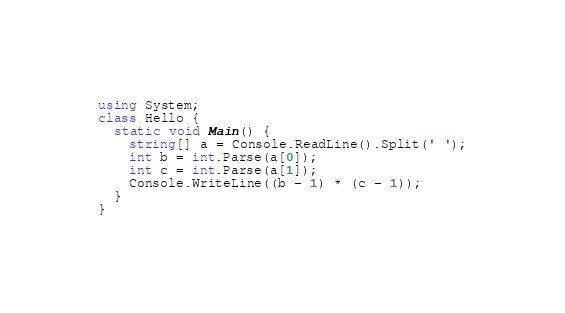<code> <loc_0><loc_0><loc_500><loc_500><_C#_>using System;
class Hello {
  static void Main() {
    string[] a = Console.ReadLine().Split(' ');
    int b = int.Parse(a[0]);
    int c = int.Parse(a[1]);
    Console.WriteLine((b - 1) * (c - 1));
  }
}</code> 